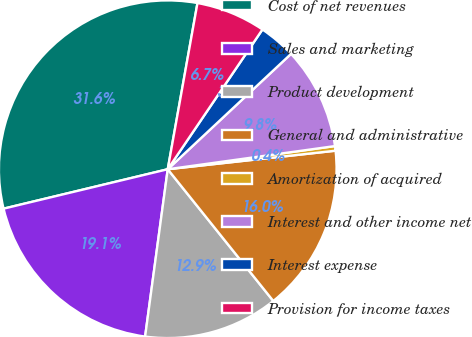Convert chart to OTSL. <chart><loc_0><loc_0><loc_500><loc_500><pie_chart><fcel>Cost of net revenues<fcel>Sales and marketing<fcel>Product development<fcel>General and administrative<fcel>Amortization of acquired<fcel>Interest and other income net<fcel>Interest expense<fcel>Provision for income taxes<nl><fcel>31.57%<fcel>19.11%<fcel>12.89%<fcel>16.0%<fcel>0.44%<fcel>9.78%<fcel>3.55%<fcel>6.66%<nl></chart> 